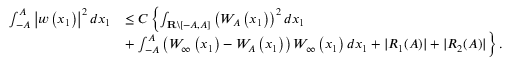<formula> <loc_0><loc_0><loc_500><loc_500>\begin{array} { r l } { \int _ { - A } ^ { A } \left | w \left ( x _ { 1 } \right ) \right | ^ { 2 } d x _ { 1 } } & { \leq C \left \{ \int _ { R \ [ - A , A ] } \left ( W _ { A } \left ( x _ { 1 } \right ) \right ) ^ { 2 } d x _ { 1 } } \\ & { + \int _ { - A } ^ { A } \left ( W _ { \infty } \left ( x _ { 1 } \right ) - W _ { A } \left ( x _ { 1 } \right ) \right ) W _ { \infty } \left ( x _ { 1 } \right ) d x _ { 1 } + | R _ { 1 } ( A ) | + | R _ { 2 } ( A ) | \right \} . } \end{array}</formula> 